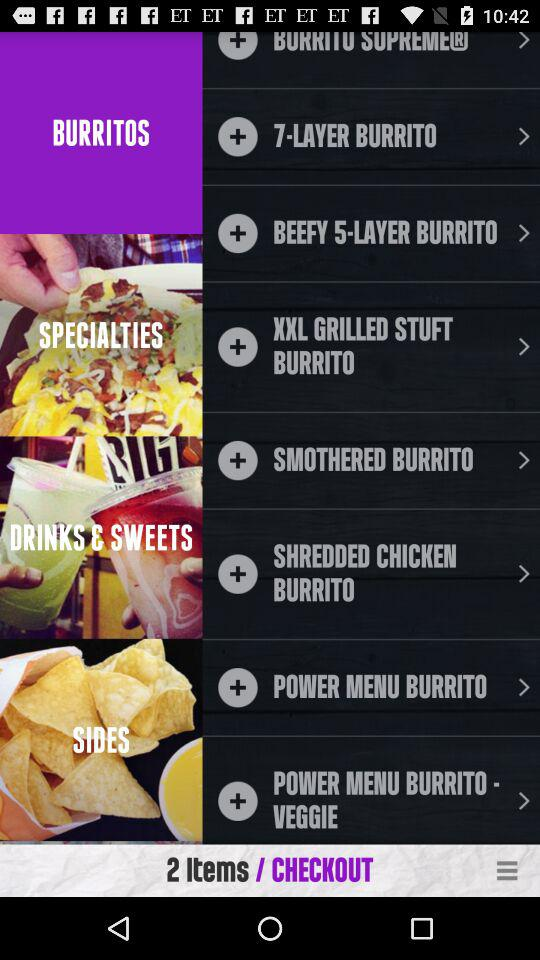How many items are in the cart?
Answer the question using a single word or phrase. 2 